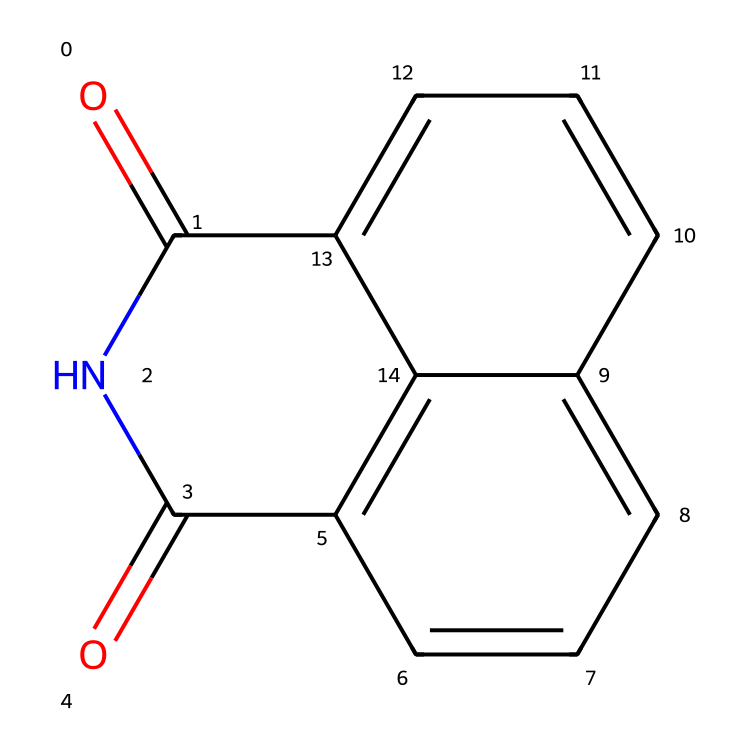What is the IUPAC name of the chemical? The SMILES representation indicates this compound is an imide due to the presence of the carbonyl groups (C=O) bonded to the nitrogen atom. The structure further reveals it has a naphthalene core, leading us to name it as naphthalimide.
Answer: naphthalimide How many carbon atoms are in the compound? Counting the carbon (C) atoms in the provided SMILES string, there are a total of 12 carbon atoms in the structure, observed both in the naphthalene rings and the imide functional group.
Answer: 12 What type of functional group is present in this molecule? The presence of two carbonyl (C=O) groups directly attached to the nitrogen atom indicates that this molecule contains an imide functional group.
Answer: imide Is there an aromatic system in this compound? The chemical structure includes a fused ring system (naphthalene), which has conjugated pi bonds, confirming the presence of an aromatic system.
Answer: yes How many nitrogen atoms does this structure contain? Inspecting the SMILES representation, indicates there are two nitrogen atoms in total, one in each of the imide functional groups.
Answer: 1 What is the potential application of naphthalimide in gaming merchandise? Naphthalimide is often used in fluorescent dyes, which enhances the visibility and aesthetic appeal of gaming merchandise, contributing to design elements.
Answer: fluorescent dyes 